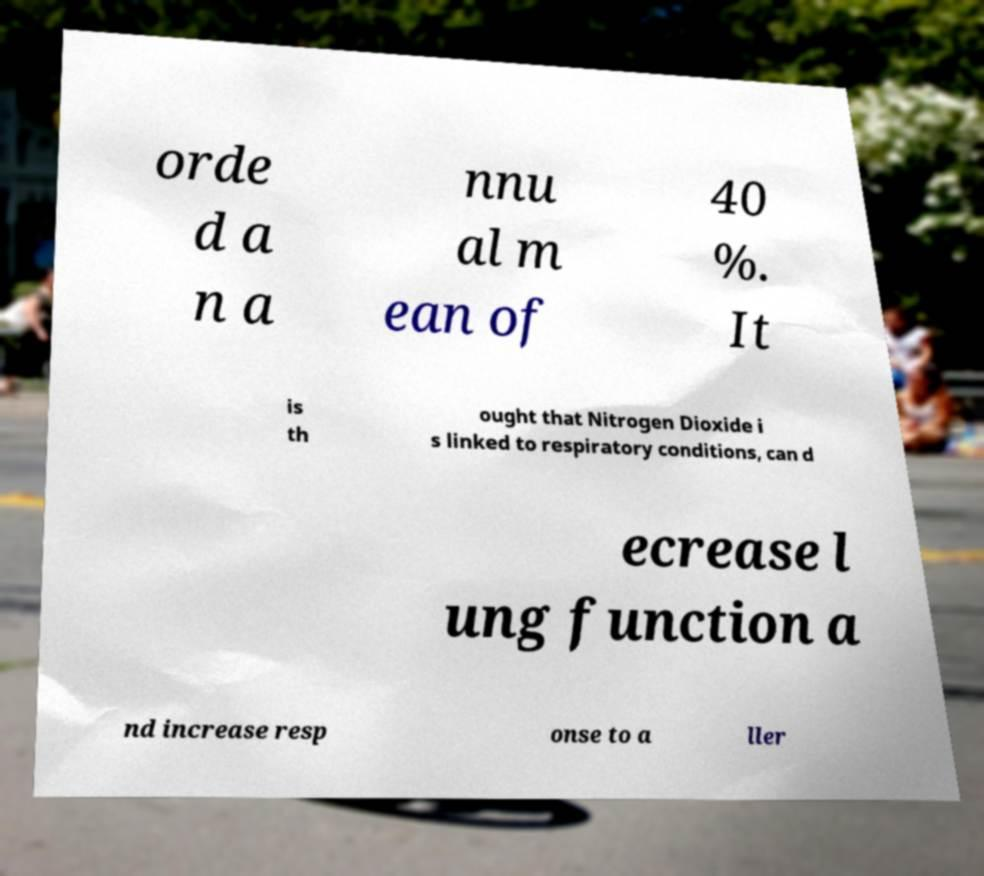Can you read and provide the text displayed in the image?This photo seems to have some interesting text. Can you extract and type it out for me? orde d a n a nnu al m ean of 40 %. It is th ought that Nitrogen Dioxide i s linked to respiratory conditions, can d ecrease l ung function a nd increase resp onse to a ller 